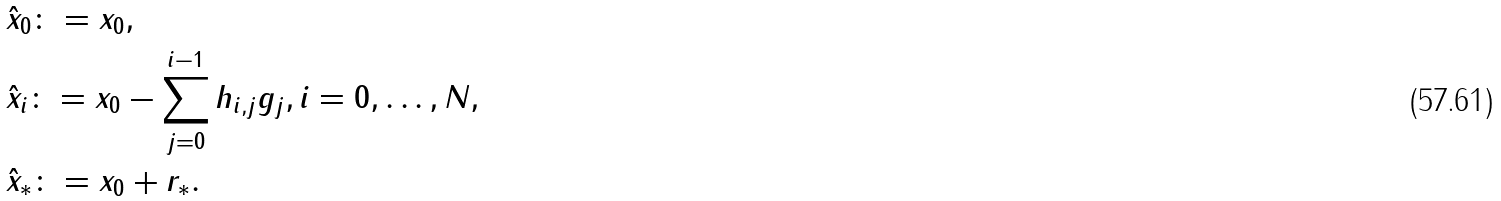Convert formula to latex. <formula><loc_0><loc_0><loc_500><loc_500>& \hat { x } _ { 0 } \colon = x _ { 0 } , \\ & \hat { x } _ { i } \colon = x _ { 0 } - \sum _ { j = 0 } ^ { i - 1 } h _ { i , j } g _ { j } , { i = 0 , \hdots , N } , \\ & \hat { x } _ { * } \colon = x _ { 0 } + r _ { * } .</formula> 